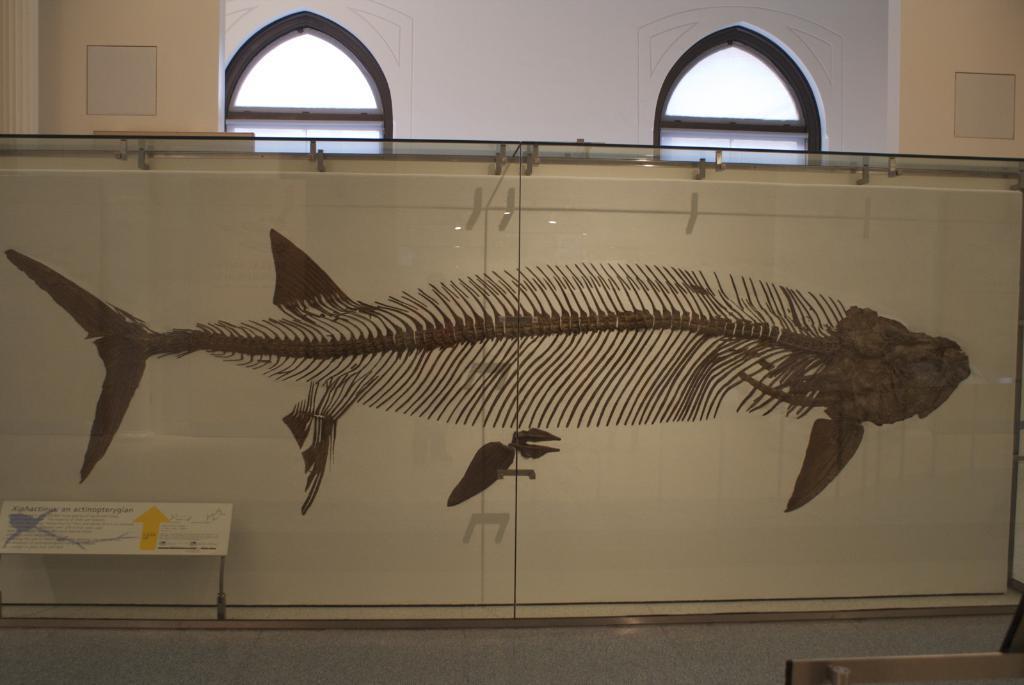Please provide a concise description of this image. In this image we can see the structure of a fish inside the box and there is the board with the text and at the back we can see the wall with windows and pillars. 